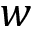<formula> <loc_0><loc_0><loc_500><loc_500>w</formula> 